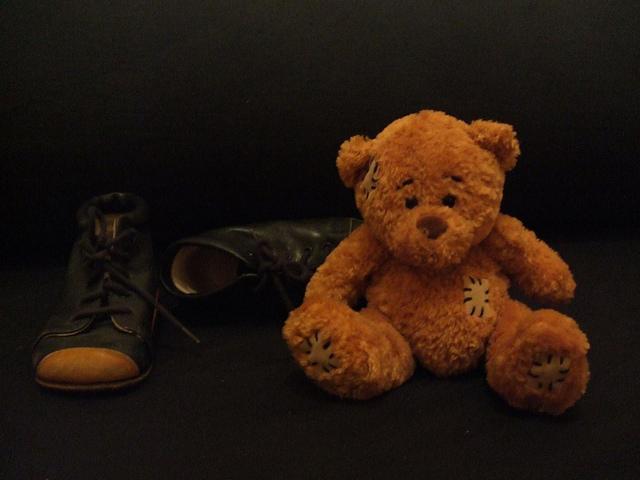How many teddy bears?
Give a very brief answer. 1. How many of the teddy bears have pants?
Give a very brief answer. 0. 